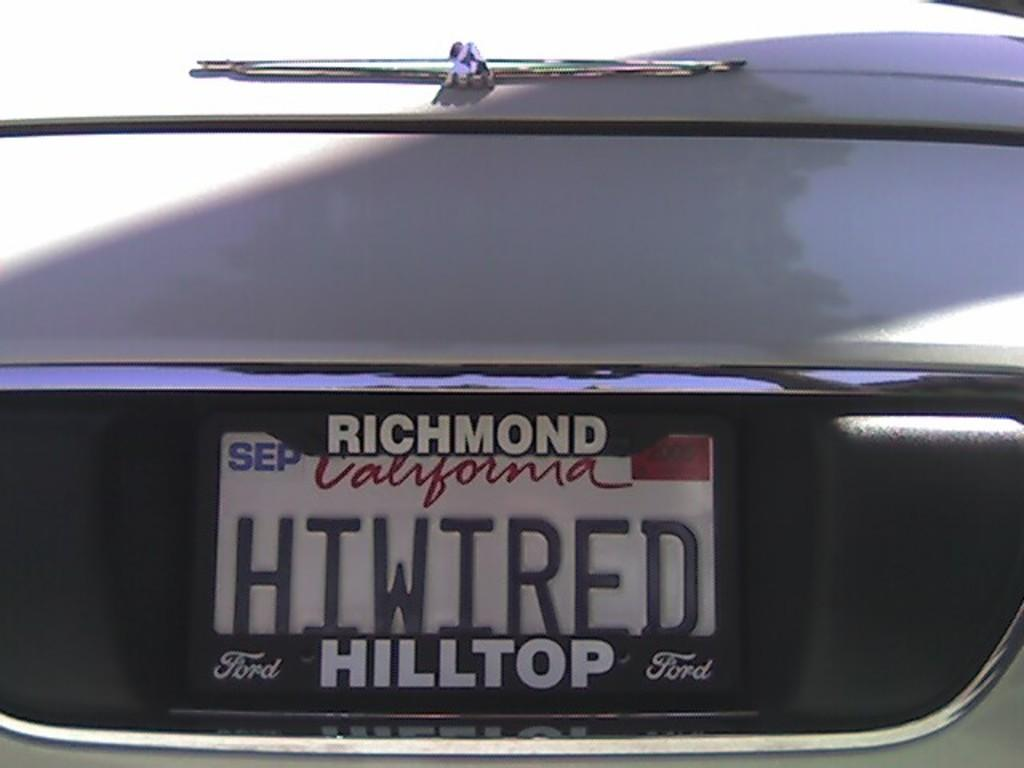Provide a one-sentence caption for the provided image. A picture of a California Plate saying HTWIRED. 